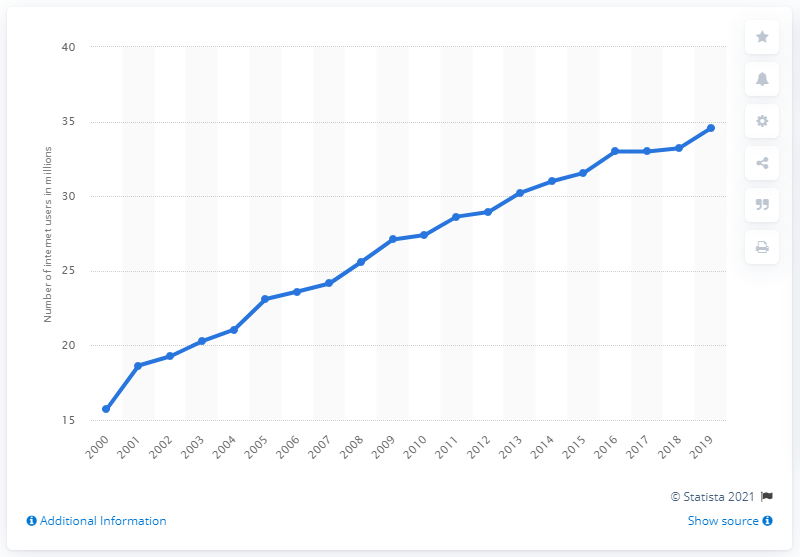Mention a couple of crucial points in this snapshot. In 2019, there were approximately 34.56 million internet users in Canada. 